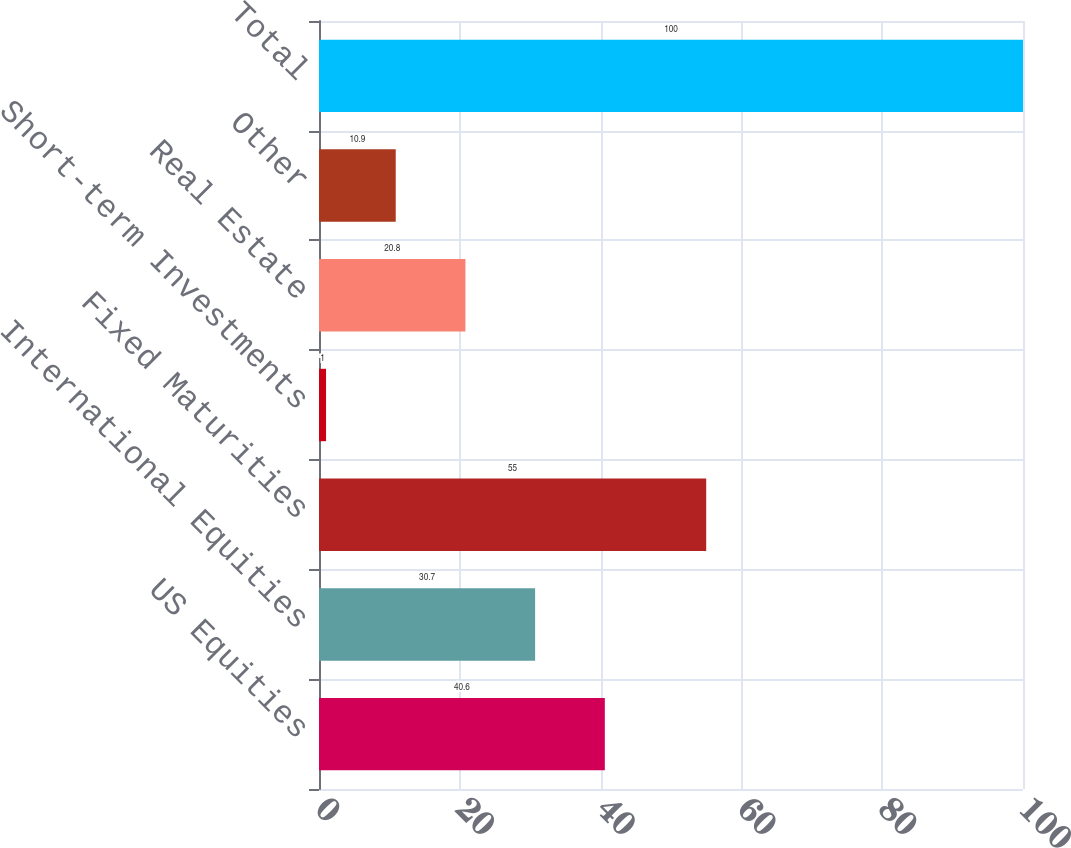<chart> <loc_0><loc_0><loc_500><loc_500><bar_chart><fcel>US Equities<fcel>International Equities<fcel>Fixed Maturities<fcel>Short-term Investments<fcel>Real Estate<fcel>Other<fcel>Total<nl><fcel>40.6<fcel>30.7<fcel>55<fcel>1<fcel>20.8<fcel>10.9<fcel>100<nl></chart> 